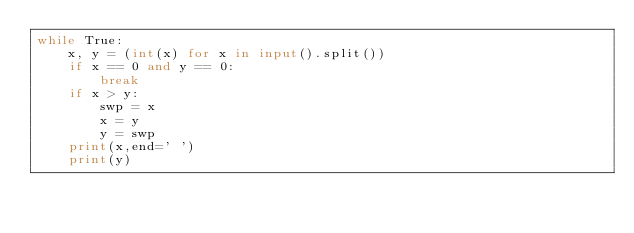<code> <loc_0><loc_0><loc_500><loc_500><_Python_>while True:
    x, y = (int(x) for x in input().split())
    if x == 0 and y == 0:
        break
    if x > y:
        swp = x
        x = y
        y = swp
    print(x,end=' ')
    print(y)
</code> 